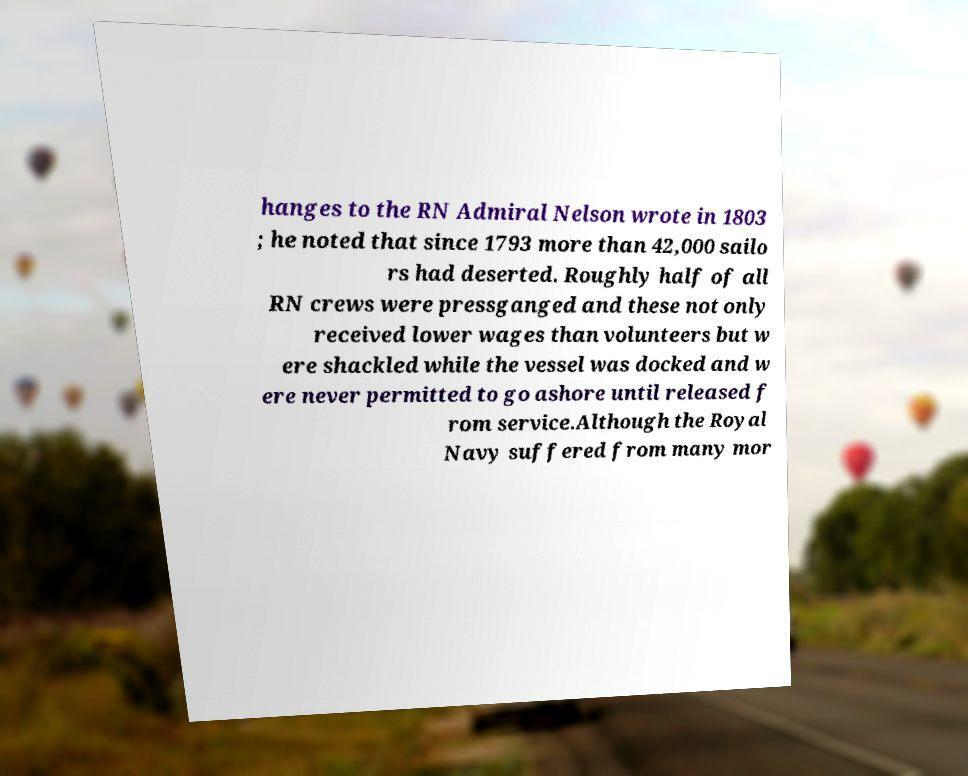Can you accurately transcribe the text from the provided image for me? hanges to the RN Admiral Nelson wrote in 1803 ; he noted that since 1793 more than 42,000 sailo rs had deserted. Roughly half of all RN crews were pressganged and these not only received lower wages than volunteers but w ere shackled while the vessel was docked and w ere never permitted to go ashore until released f rom service.Although the Royal Navy suffered from many mor 